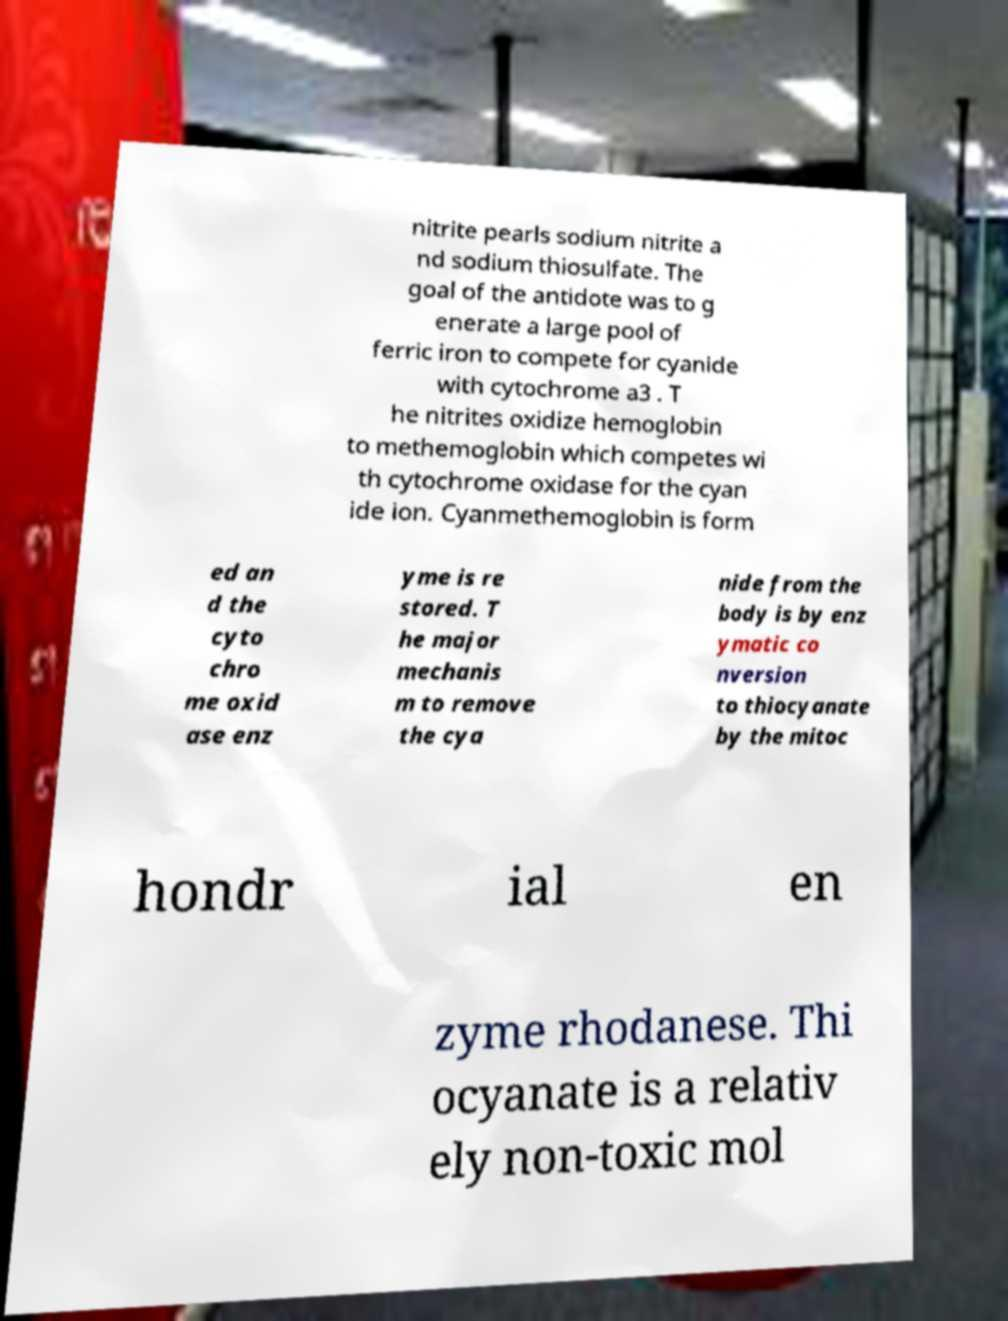What messages or text are displayed in this image? I need them in a readable, typed format. nitrite pearls sodium nitrite a nd sodium thiosulfate. The goal of the antidote was to g enerate a large pool of ferric iron to compete for cyanide with cytochrome a3 . T he nitrites oxidize hemoglobin to methemoglobin which competes wi th cytochrome oxidase for the cyan ide ion. Cyanmethemoglobin is form ed an d the cyto chro me oxid ase enz yme is re stored. T he major mechanis m to remove the cya nide from the body is by enz ymatic co nversion to thiocyanate by the mitoc hondr ial en zyme rhodanese. Thi ocyanate is a relativ ely non-toxic mol 